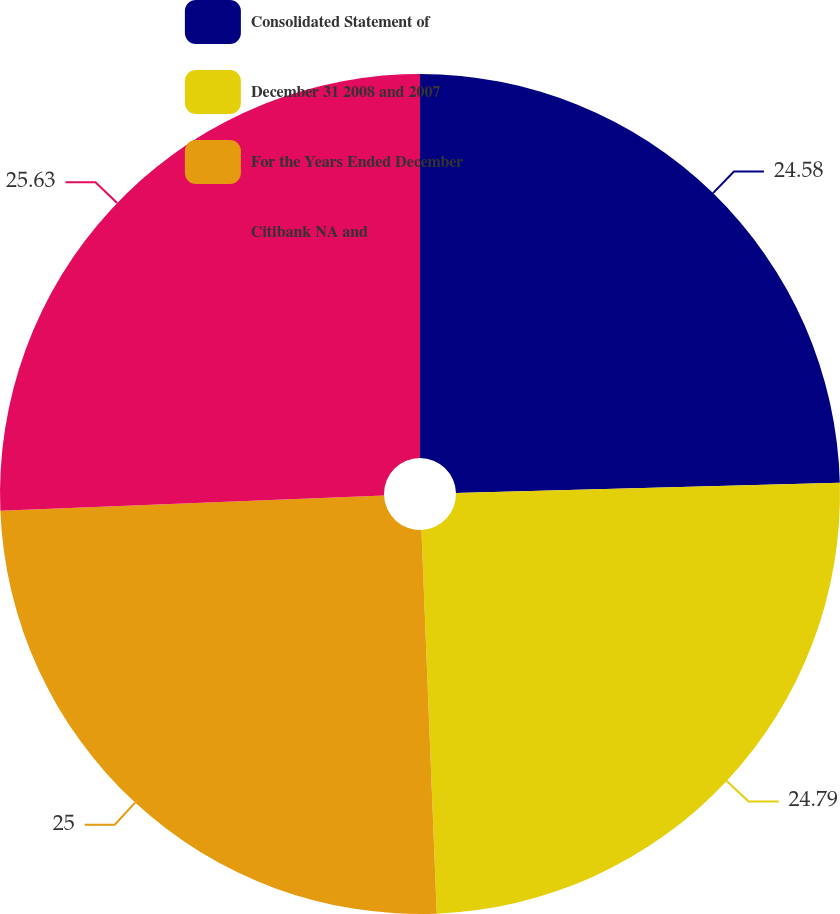Convert chart. <chart><loc_0><loc_0><loc_500><loc_500><pie_chart><fcel>Consolidated Statement of<fcel>December 31 2008 and 2007<fcel>For the Years Ended December<fcel>Citibank NA and<nl><fcel>24.58%<fcel>24.79%<fcel>25.0%<fcel>25.64%<nl></chart> 